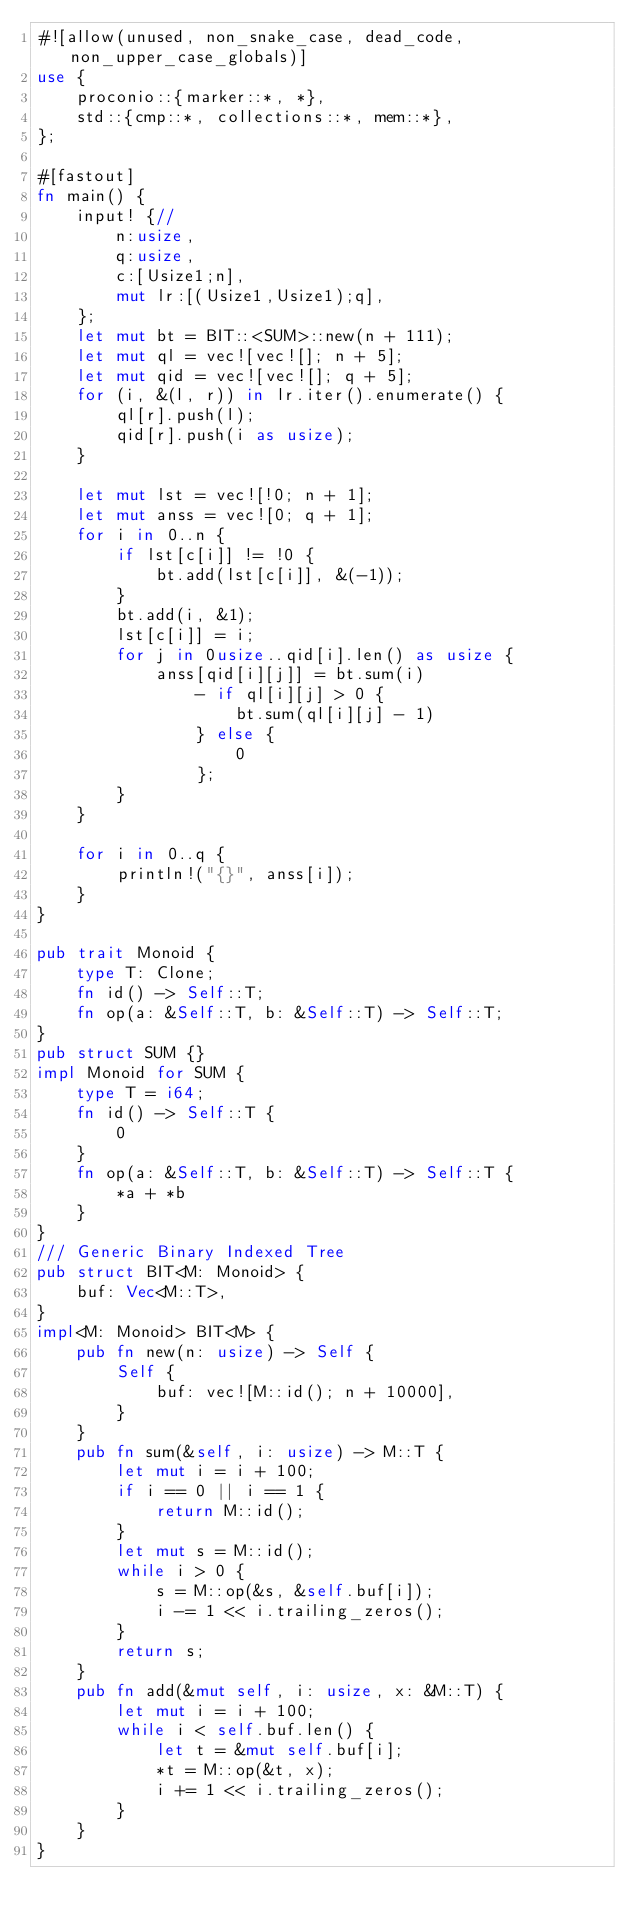Convert code to text. <code><loc_0><loc_0><loc_500><loc_500><_Rust_>#![allow(unused, non_snake_case, dead_code, non_upper_case_globals)]
use {
    proconio::{marker::*, *},
    std::{cmp::*, collections::*, mem::*},
};

#[fastout]
fn main() {
    input! {//
        n:usize,
        q:usize,
        c:[Usize1;n],
        mut lr:[(Usize1,Usize1);q],
    };
    let mut bt = BIT::<SUM>::new(n + 111);
    let mut ql = vec![vec![]; n + 5];
    let mut qid = vec![vec![]; q + 5];
    for (i, &(l, r)) in lr.iter().enumerate() {
        ql[r].push(l);
        qid[r].push(i as usize);
    }

    let mut lst = vec![!0; n + 1];
    let mut anss = vec![0; q + 1];
    for i in 0..n {
        if lst[c[i]] != !0 {
            bt.add(lst[c[i]], &(-1));
        }
        bt.add(i, &1);
        lst[c[i]] = i;
        for j in 0usize..qid[i].len() as usize {
            anss[qid[i][j]] = bt.sum(i)
                - if ql[i][j] > 0 {
                    bt.sum(ql[i][j] - 1)
                } else {
                    0
                };
        }
    }

    for i in 0..q {
        println!("{}", anss[i]);
    }
}

pub trait Monoid {
    type T: Clone;
    fn id() -> Self::T;
    fn op(a: &Self::T, b: &Self::T) -> Self::T;
}
pub struct SUM {}
impl Monoid for SUM {
    type T = i64;
    fn id() -> Self::T {
        0
    }
    fn op(a: &Self::T, b: &Self::T) -> Self::T {
        *a + *b
    }
}
/// Generic Binary Indexed Tree
pub struct BIT<M: Monoid> {
    buf: Vec<M::T>,
}
impl<M: Monoid> BIT<M> {
    pub fn new(n: usize) -> Self {
        Self {
            buf: vec![M::id(); n + 10000],
        }
    }
    pub fn sum(&self, i: usize) -> M::T {
        let mut i = i + 100;
        if i == 0 || i == 1 {
            return M::id();
        }
        let mut s = M::id();
        while i > 0 {
            s = M::op(&s, &self.buf[i]);
            i -= 1 << i.trailing_zeros();
        }
        return s;
    }
    pub fn add(&mut self, i: usize, x: &M::T) {
        let mut i = i + 100;
        while i < self.buf.len() {
            let t = &mut self.buf[i];
            *t = M::op(&t, x);
            i += 1 << i.trailing_zeros();
        }
    }
}
</code> 